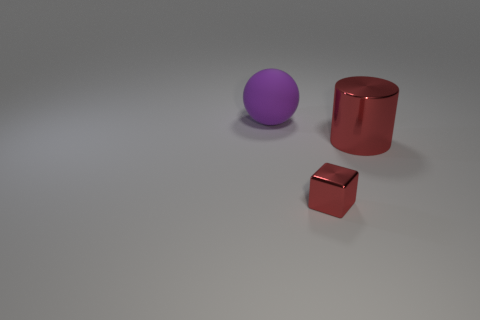There is another metallic thing that is the same color as the large metal object; what is its shape?
Give a very brief answer. Cube. Is the material of the red thing to the left of the big red metal cylinder the same as the sphere?
Your answer should be compact. No. What shape is the shiny thing right of the red object in front of the big object to the right of the purple object?
Offer a very short reply. Cylinder. What number of green things are either blocks or large rubber things?
Provide a succinct answer. 0. Are there the same number of cubes in front of the ball and rubber objects right of the metallic cylinder?
Your answer should be compact. No. Does the big object that is right of the purple ball have the same shape as the large thing on the left side of the small cube?
Provide a short and direct response. No. Are there any other things that have the same shape as the purple thing?
Your answer should be compact. No. The red object that is made of the same material as the red cylinder is what shape?
Provide a succinct answer. Cube. Are there an equal number of big metallic things on the left side of the tiny red thing and tiny things?
Provide a succinct answer. No. Do the thing on the right side of the red cube and the big thing that is behind the red cylinder have the same material?
Ensure brevity in your answer.  No. 